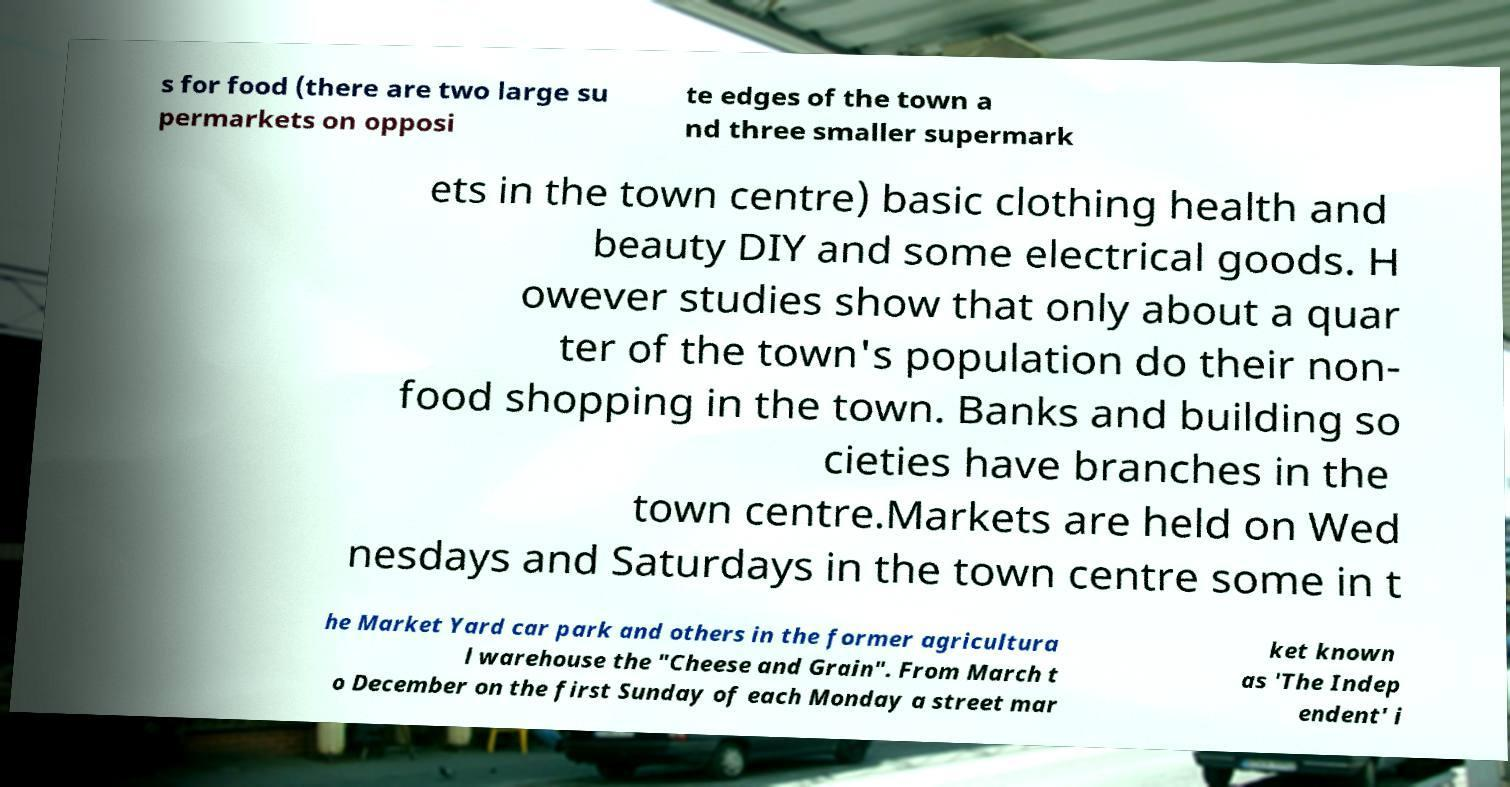Please identify and transcribe the text found in this image. s for food (there are two large su permarkets on opposi te edges of the town a nd three smaller supermark ets in the town centre) basic clothing health and beauty DIY and some electrical goods. H owever studies show that only about a quar ter of the town's population do their non- food shopping in the town. Banks and building so cieties have branches in the town centre.Markets are held on Wed nesdays and Saturdays in the town centre some in t he Market Yard car park and others in the former agricultura l warehouse the "Cheese and Grain". From March t o December on the first Sunday of each Monday a street mar ket known as 'The Indep endent' i 